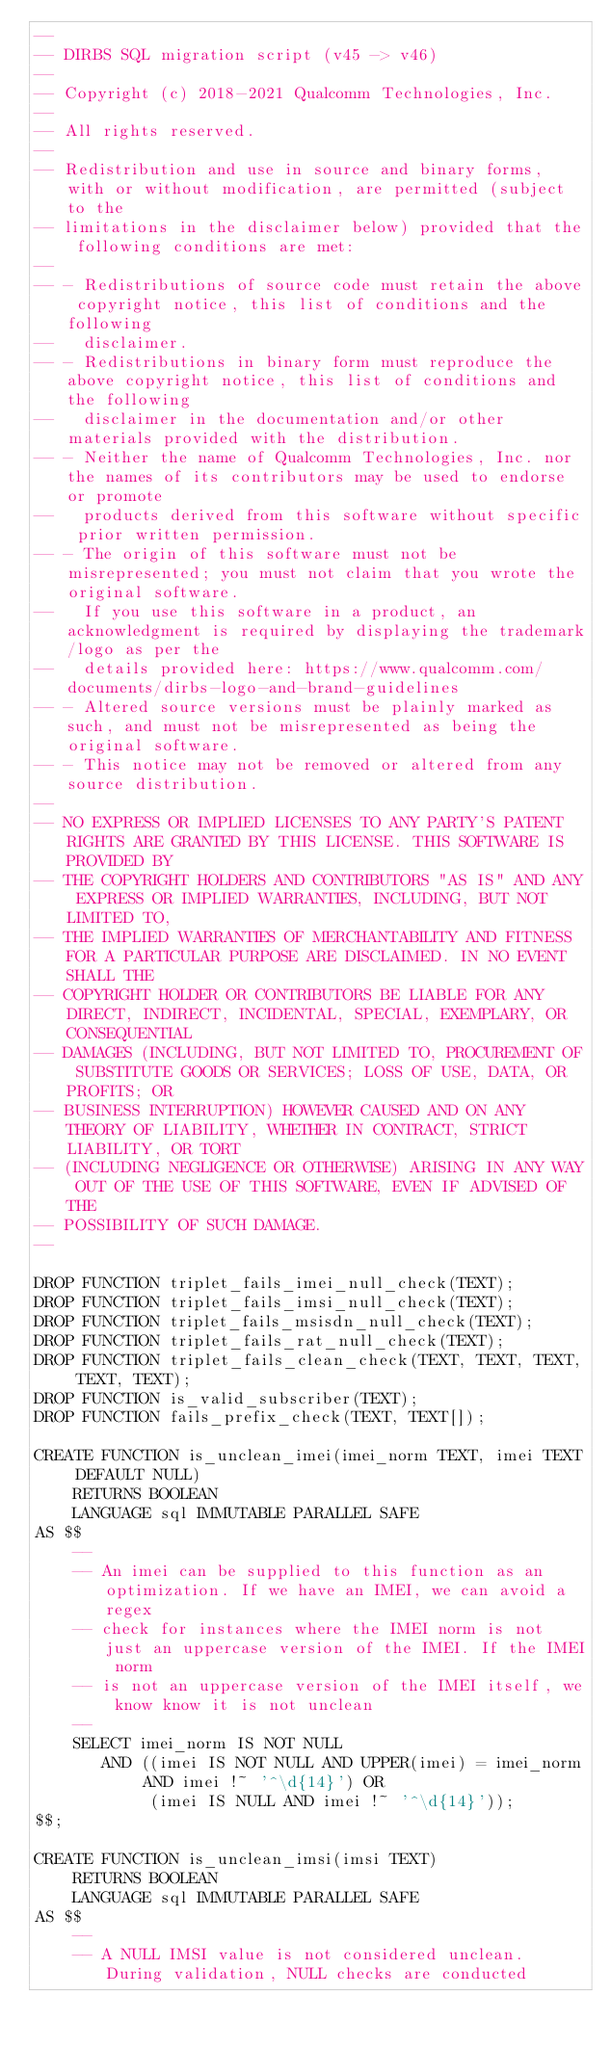Convert code to text. <code><loc_0><loc_0><loc_500><loc_500><_SQL_>--
-- DIRBS SQL migration script (v45 -> v46)
--
-- Copyright (c) 2018-2021 Qualcomm Technologies, Inc.
--
-- All rights reserved.
--
-- Redistribution and use in source and binary forms, with or without modification, are permitted (subject to the
-- limitations in the disclaimer below) provided that the following conditions are met:
--
-- - Redistributions of source code must retain the above copyright notice, this list of conditions and the following
--   disclaimer.
-- - Redistributions in binary form must reproduce the above copyright notice, this list of conditions and the following
--   disclaimer in the documentation and/or other materials provided with the distribution.
-- - Neither the name of Qualcomm Technologies, Inc. nor the names of its contributors may be used to endorse or promote
--   products derived from this software without specific prior written permission.
-- - The origin of this software must not be misrepresented; you must not claim that you wrote the original software.
--   If you use this software in a product, an acknowledgment is required by displaying the trademark/logo as per the
--   details provided here: https://www.qualcomm.com/documents/dirbs-logo-and-brand-guidelines
-- - Altered source versions must be plainly marked as such, and must not be misrepresented as being the original software.
-- - This notice may not be removed or altered from any source distribution.
--
-- NO EXPRESS OR IMPLIED LICENSES TO ANY PARTY'S PATENT RIGHTS ARE GRANTED BY THIS LICENSE. THIS SOFTWARE IS PROVIDED BY
-- THE COPYRIGHT HOLDERS AND CONTRIBUTORS "AS IS" AND ANY EXPRESS OR IMPLIED WARRANTIES, INCLUDING, BUT NOT LIMITED TO,
-- THE IMPLIED WARRANTIES OF MERCHANTABILITY AND FITNESS FOR A PARTICULAR PURPOSE ARE DISCLAIMED. IN NO EVENT SHALL THE
-- COPYRIGHT HOLDER OR CONTRIBUTORS BE LIABLE FOR ANY DIRECT, INDIRECT, INCIDENTAL, SPECIAL, EXEMPLARY, OR CONSEQUENTIAL
-- DAMAGES (INCLUDING, BUT NOT LIMITED TO, PROCUREMENT OF SUBSTITUTE GOODS OR SERVICES; LOSS OF USE, DATA, OR PROFITS; OR
-- BUSINESS INTERRUPTION) HOWEVER CAUSED AND ON ANY THEORY OF LIABILITY, WHETHER IN CONTRACT, STRICT LIABILITY, OR TORT
-- (INCLUDING NEGLIGENCE OR OTHERWISE) ARISING IN ANY WAY OUT OF THE USE OF THIS SOFTWARE, EVEN IF ADVISED OF THE
-- POSSIBILITY OF SUCH DAMAGE.
--

DROP FUNCTION triplet_fails_imei_null_check(TEXT);
DROP FUNCTION triplet_fails_imsi_null_check(TEXT);
DROP FUNCTION triplet_fails_msisdn_null_check(TEXT);
DROP FUNCTION triplet_fails_rat_null_check(TEXT);
DROP FUNCTION triplet_fails_clean_check(TEXT, TEXT, TEXT, TEXT, TEXT);
DROP FUNCTION is_valid_subscriber(TEXT);
DROP FUNCTION fails_prefix_check(TEXT, TEXT[]);

CREATE FUNCTION is_unclean_imei(imei_norm TEXT, imei TEXT DEFAULT NULL)
    RETURNS BOOLEAN
    LANGUAGE sql IMMUTABLE PARALLEL SAFE
AS $$
    --
    -- An imei can be supplied to this function as an optimization. If we have an IMEI, we can avoid a regex
    -- check for instances where the IMEI norm is not just an uppercase version of the IMEI. If the IMEI norm
    -- is not an uppercase version of the IMEI itself, we know know it is not unclean
    --
    SELECT imei_norm IS NOT NULL
       AND ((imei IS NOT NULL AND UPPER(imei) = imei_norm AND imei !~ '^\d{14}') OR
            (imei IS NULL AND imei !~ '^\d{14}'));
$$;

CREATE FUNCTION is_unclean_imsi(imsi TEXT)
    RETURNS BOOLEAN
    LANGUAGE sql IMMUTABLE PARALLEL SAFE
AS $$
    --
    -- A NULL IMSI value is not considered unclean. During validation, NULL checks are conducted</code> 